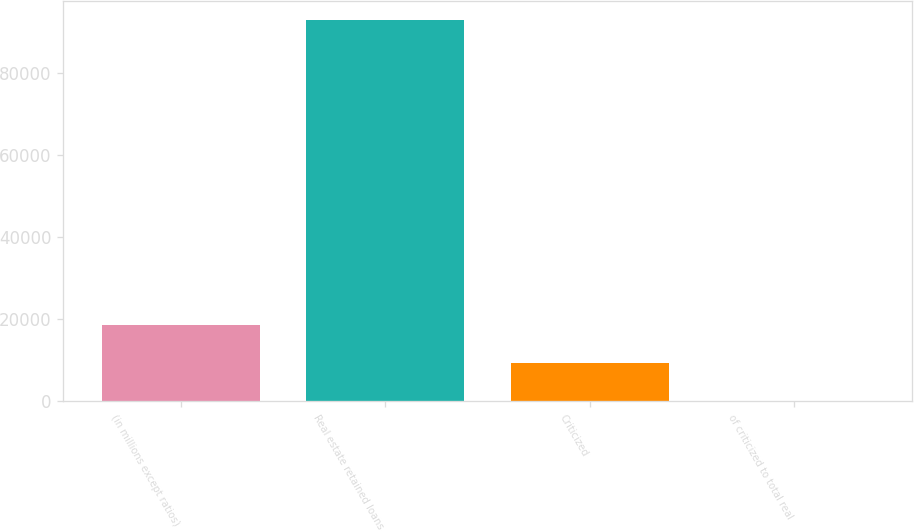Convert chart to OTSL. <chart><loc_0><loc_0><loc_500><loc_500><bar_chart><fcel>(in millions except ratios)<fcel>Real estate retained loans<fcel>Criticized<fcel>of criticized to total real<nl><fcel>18565.3<fcel>92820<fcel>9283.44<fcel>1.6<nl></chart> 